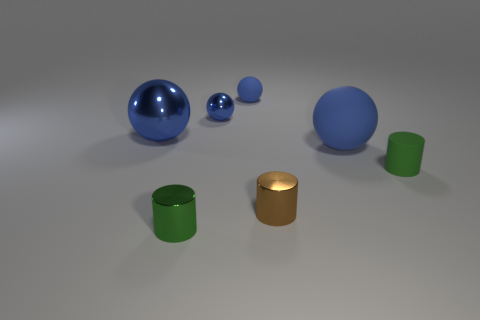What shape is the object that is the same color as the tiny matte cylinder?
Your answer should be compact. Cylinder. Are there an equal number of metal spheres in front of the small metallic sphere and small matte things behind the brown cylinder?
Offer a terse response. No. There is another tiny matte thing that is the same shape as the brown thing; what color is it?
Your answer should be very brief. Green. Is there any other thing that is the same shape as the small brown metal object?
Your response must be concise. Yes. There is a shiny object to the left of the green metallic thing; does it have the same color as the small rubber cylinder?
Provide a short and direct response. No. There is a rubber object that is the same shape as the tiny brown metallic thing; what size is it?
Your response must be concise. Small. How many brown things have the same material as the tiny brown cylinder?
Provide a short and direct response. 0. Is there a brown metallic object that is right of the small green thing that is right of the big blue thing that is in front of the large blue metallic sphere?
Keep it short and to the point. No. What is the shape of the green metal object?
Offer a terse response. Cylinder. Is the material of the object in front of the small brown cylinder the same as the blue ball right of the small brown metallic cylinder?
Your answer should be compact. No. 